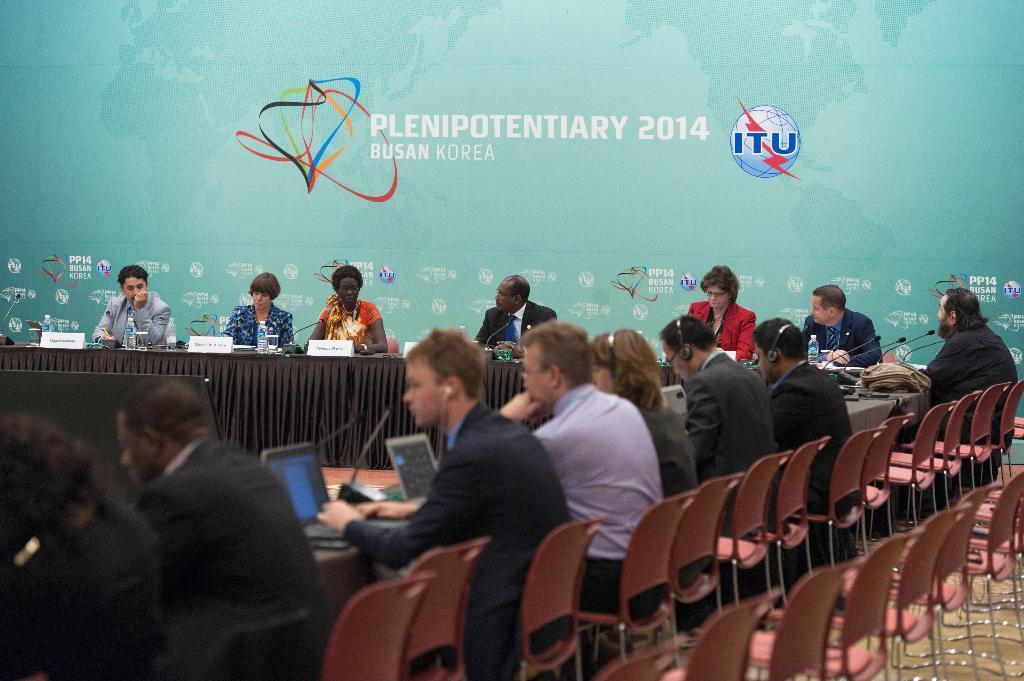How would you summarize this image in a sentence or two? This image consists of table, chairs. On the tables there are water bottles, Mike's, name boards, pens. On the chairs there are people sitting. 